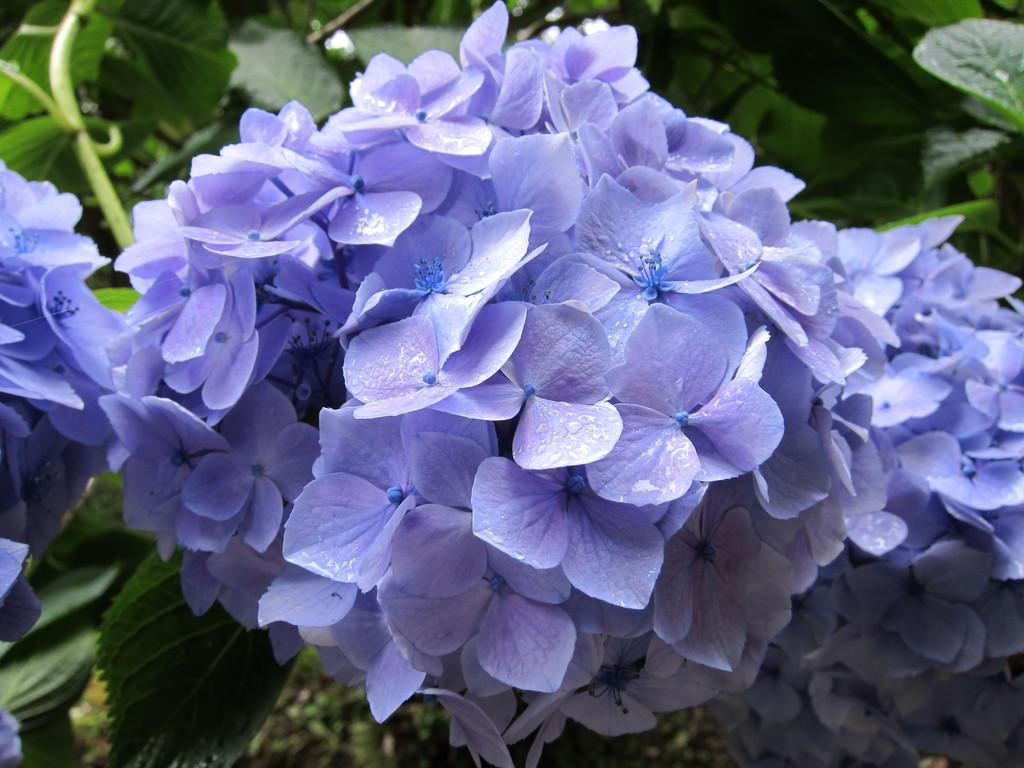What type of plant life can be seen in the image? There are flowers, leaves, and plants visible in the image. Can you describe the specific elements of the plants in the image? The flowers and leaves are part of the plants in the image. What is the general theme or subject of the image? The image features plant life, including flowers, leaves, and plants. What type of unit can be seen measuring the length of the icicle in the image? There is no icicle or unit present in the image; it features flowers, leaves, and plants. 